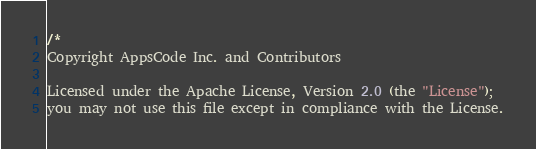<code> <loc_0><loc_0><loc_500><loc_500><_Go_>/*
Copyright AppsCode Inc. and Contributors

Licensed under the Apache License, Version 2.0 (the "License");
you may not use this file except in compliance with the License.</code> 